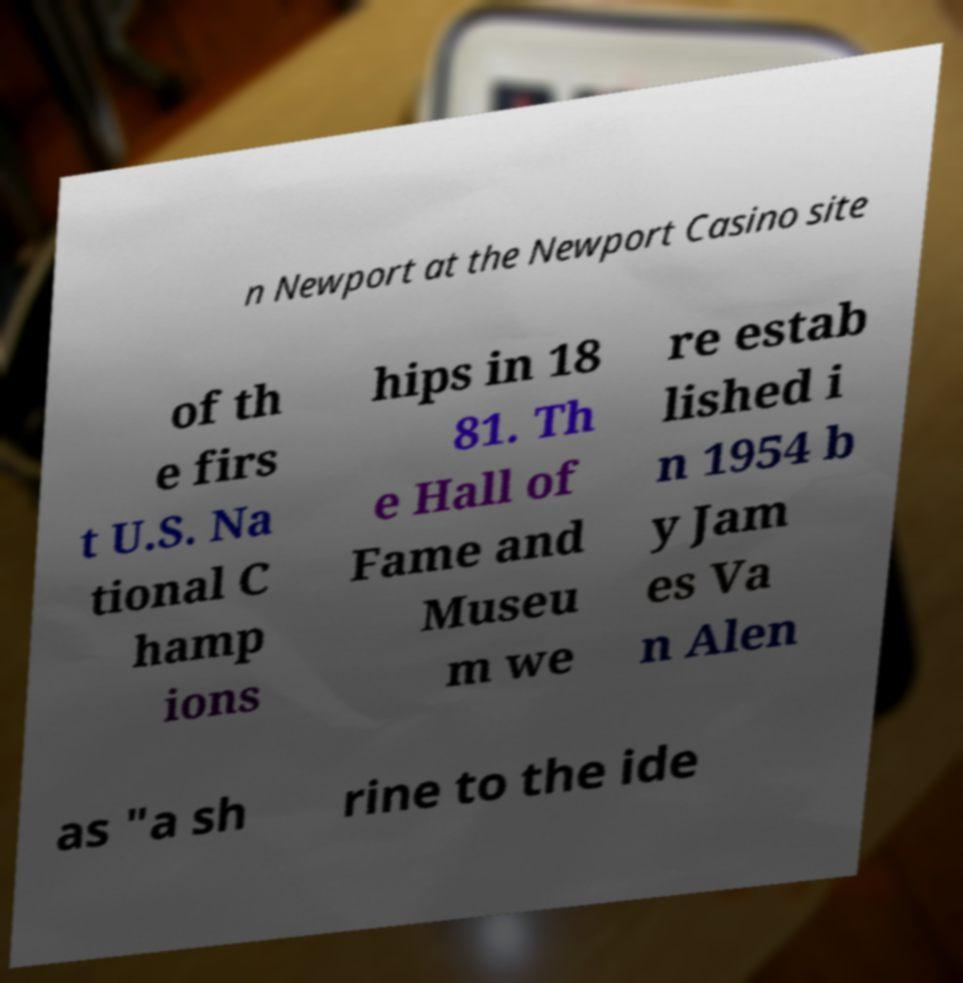Please identify and transcribe the text found in this image. n Newport at the Newport Casino site of th e firs t U.S. Na tional C hamp ions hips in 18 81. Th e Hall of Fame and Museu m we re estab lished i n 1954 b y Jam es Va n Alen as "a sh rine to the ide 